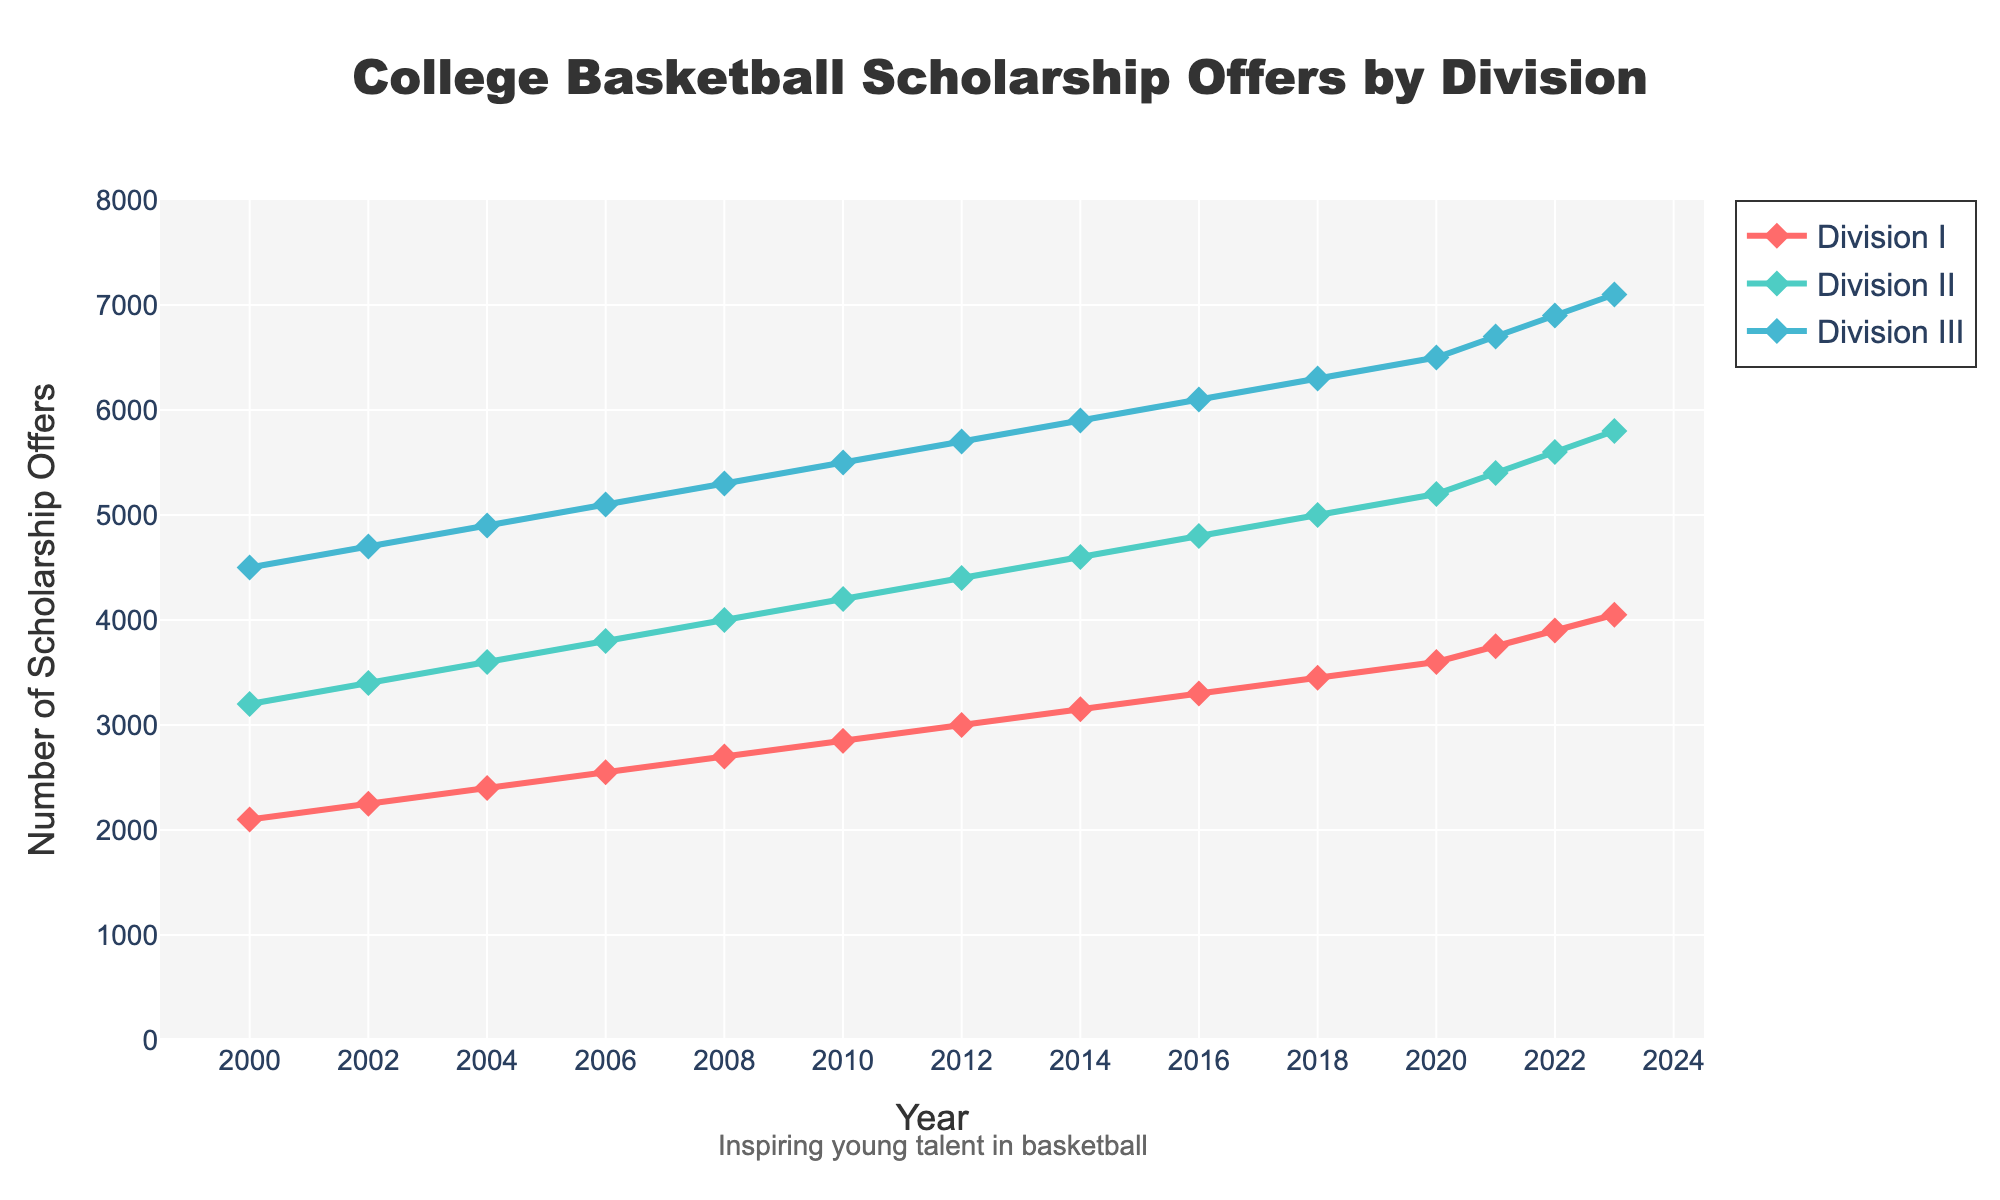What is the trend in the number of Division I scholarship offers from 2000 to 2023? The line chart shows a steady increase in Division I scholarship offers from 2000, starting at 2100, and rising to 4050 in 2023.
Answer: Steady increase Which division had the most scholarship offers in 2023? In 2023, the visual inspection of the chart shows that Division III had the highest number of offers at 7100, compared to Division I and Division II.
Answer: Division III How many more offers did Division III receive compared to Division II in 2020? In 2020, Division III received 6500 offers, and Division II received 5200 offers. The difference is 6500 - 5200 = 1300.
Answer: 1300 What color represents Division II in the chart? The chart uses different colors to represent each division: Division II is represented by green.
Answer: Green On average, how many scholarship offers were given per year for Division III between 2010 and 2020? Offers for Division III in 2010, 2012, 2014, 2016, 2018, and 2020 are 5500, 5700, 5900, 6100, 6300, and 6500 respectively. The sum is 5500 + 5700 + 5900 + 6100 + 6300 + 6500 = 36000. There are 6 years, so the average is 36000 / 6 = 6000.
Answer: 6000 Which year saw the greatest number of Division II scholarship offers? The chart shows the number of offers for each year, and in 2023, Division II had the highest number at 5800.
Answer: 2023 By how much did Division I scholarship offers increase from 2008 to 2023? Division I offers in 2008 were 2700 and in 2023 were 4050. The increase is 4050 - 2700 = 1350.
Answer: 1350 Compare the scholarship offers for Division II and Division III in 2010. By what percentage was Division III higher than Division II? In 2010, Division II had 4200 offers and Division III had 5500 offers. The difference is 5500 - 4200 = 1300. The percentage increase is (1300 / 4200) * 100 ≈ 30.95%.
Answer: 30.95% How did the growth in Division III scholarship offers compare to Division I offers from 2000 to 2023? From 2000 to 2023, Division III offers grew from 4500 to 7100, a growth of 2600. Division I offers grew from 2100 to 4050, a growth of 1950. Division III had higher absolute growth.
Answer: Division III had higher absolute growth In what year did Division II scholarship offers first exceed 5000? According to the chart, Division II scholarship offers first exceeded 5000 in 2018, when the number was 5000.
Answer: 2018 